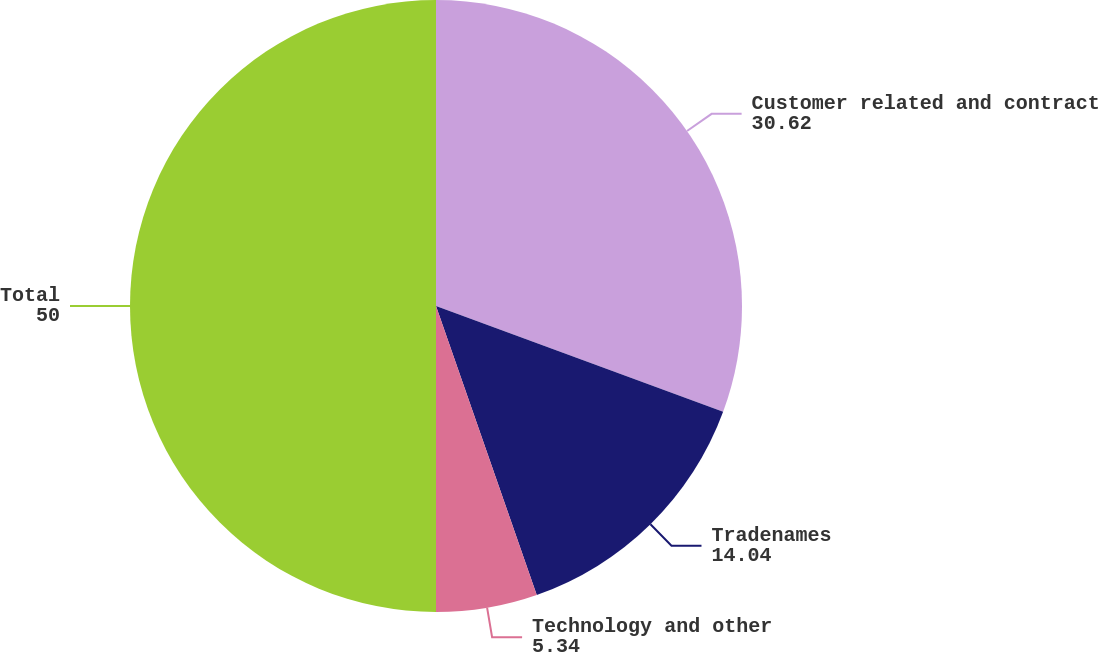Convert chart. <chart><loc_0><loc_0><loc_500><loc_500><pie_chart><fcel>Customer related and contract<fcel>Tradenames<fcel>Technology and other<fcel>Total<nl><fcel>30.62%<fcel>14.04%<fcel>5.34%<fcel>50.0%<nl></chart> 